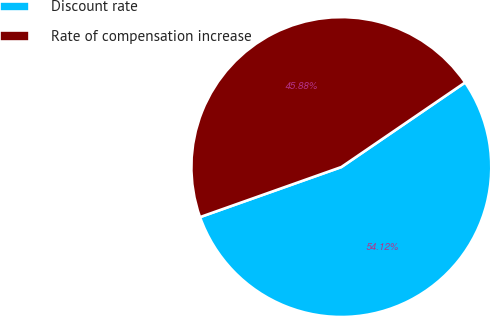Convert chart. <chart><loc_0><loc_0><loc_500><loc_500><pie_chart><fcel>Discount rate<fcel>Rate of compensation increase<nl><fcel>54.12%<fcel>45.88%<nl></chart> 